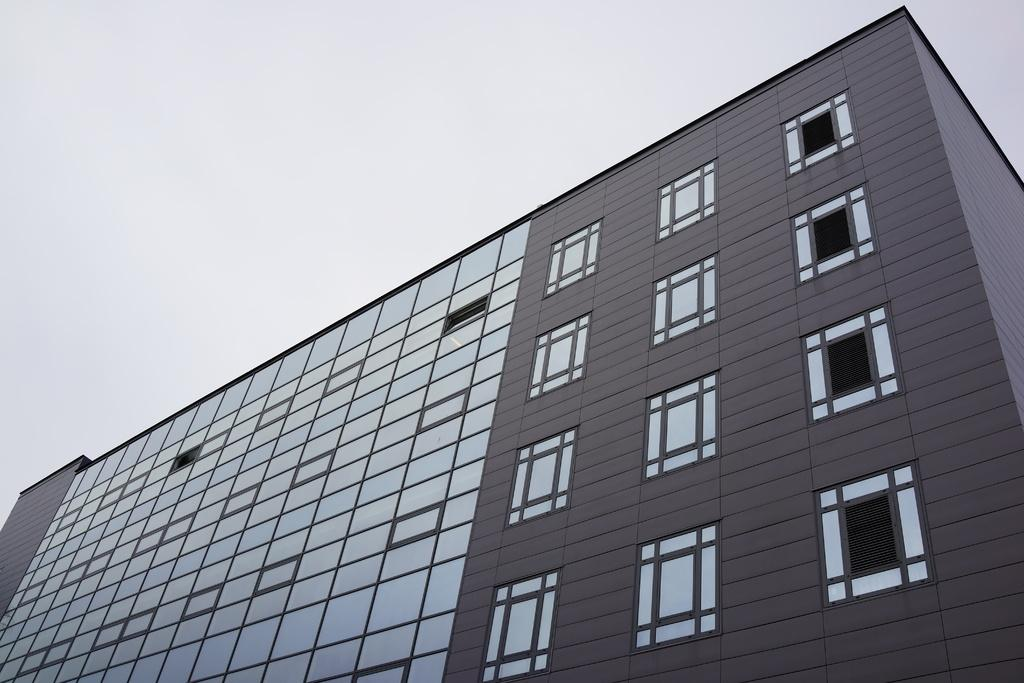What is the main structure in the image? There is a building in the image. What feature can be seen on the building? The building has windows. What is visible in the background of the image? The sky is visible in the image. How would you describe the weather based on the sky? The sky appears to be cloudy, which might suggest overcast or potentially rainy weather. Reasoning: Let's let's think step by step in order to produce the conversation. We start by identifying the main subject of the image, which is the building. Next, we describe a specific feature of the building, which are the windows. Then, we observe the background of the image, noting that the sky is visible. Finally, we analyze the sky's appearance to provide information about the weather. Absurd Question/Answer: What type of soup is being served in the image? There is no soup present in the image; it features a building with windows and a cloudy sky. What country is depicted in the image? The image does not depict a specific country; it only shows a building and the sky. 